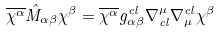<formula> <loc_0><loc_0><loc_500><loc_500>\overline { \chi ^ { \alpha } } \hat { M } _ { \alpha \beta } \chi ^ { \beta } = \overline { \chi ^ { \alpha } } g ^ { c l } _ { \alpha \beta } \nabla ^ { \mu } _ { c l } \nabla ^ { c l } _ { \mu } \chi ^ { \beta }</formula> 